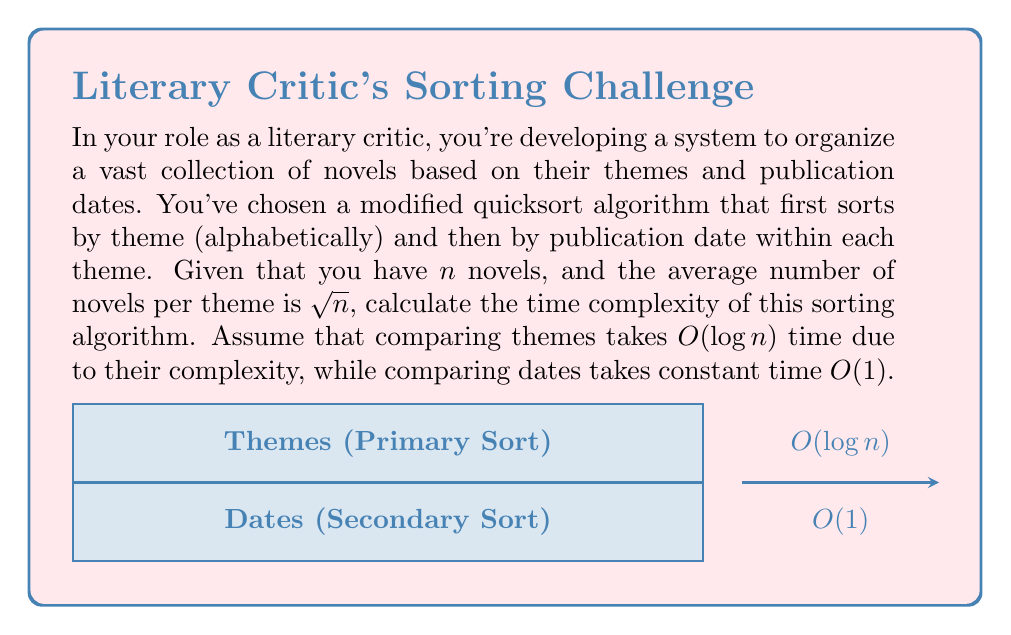Solve this math problem. Let's break this down step-by-step:

1) The quicksort algorithm has an average time complexity of $O(n \log n)$ for $n$ elements.

2) In this case, we're first sorting by theme. There are $n$ novels in total, and comparing themes takes $O(\log n)$ time. So, the time complexity for the theme sort is:

   $$O(n \log n \cdot \log n) = O(n \log^2 n)$$

3) After sorting by theme, we need to sort by date within each theme. There are $\sqrt{n}$ novels per theme on average, and we have $\frac{n}{\sqrt{n}} = \sqrt{n}$ themes.

4) Sorting $\sqrt{n}$ elements (dates) takes $O(\sqrt{n} \log \sqrt{n})$ time, and we do this for each of the $\sqrt{n}$ themes. Date comparisons are $O(1)$, so they don't affect the complexity. Thus, the time for date sorting is:

   $$O(\sqrt{n} \cdot \sqrt{n} \log \sqrt{n}) = O(n \log \sqrt{n}) = O(n \log n)$$

5) The total time complexity is the sum of the theme sorting and date sorting:

   $$O(n \log^2 n + n \log n)$$

6) The dominant term is $O(n \log^2 n)$, so this is our final time complexity.
Answer: $O(n \log^2 n)$ 